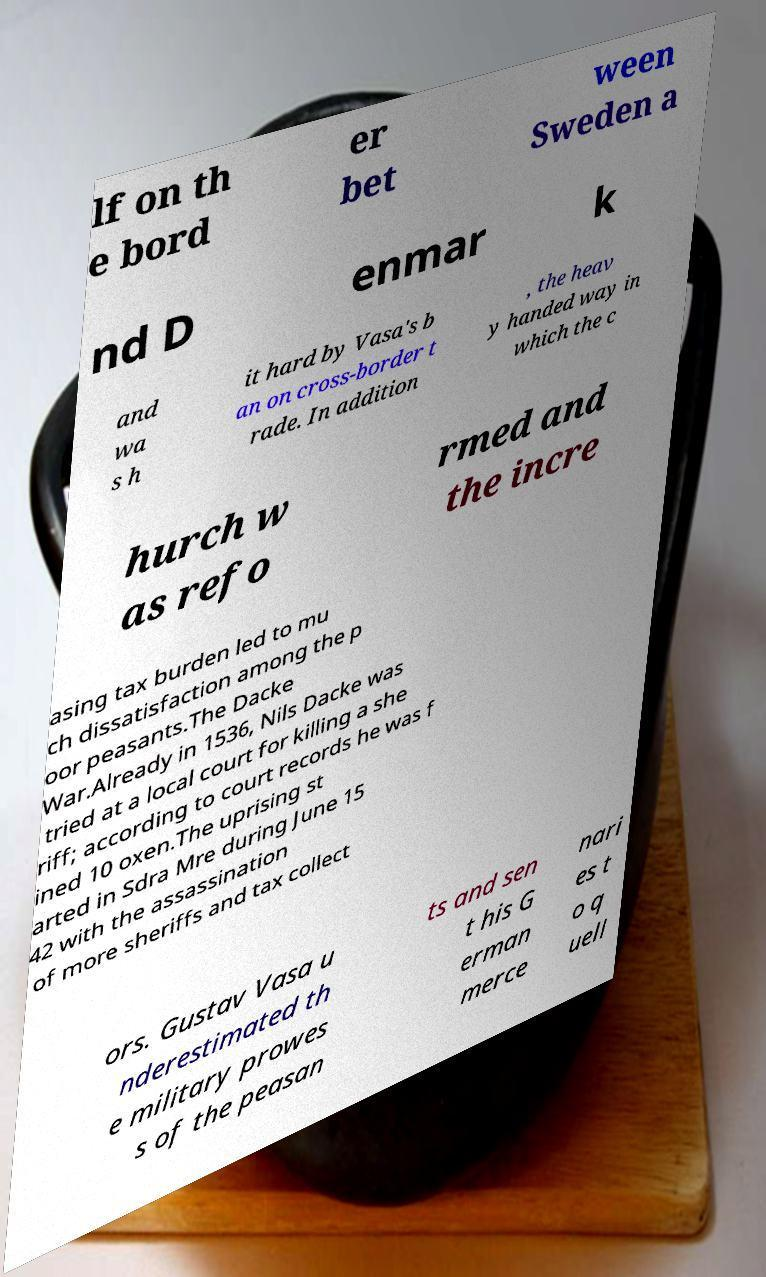For documentation purposes, I need the text within this image transcribed. Could you provide that? lf on th e bord er bet ween Sweden a nd D enmar k and wa s h it hard by Vasa's b an on cross-border t rade. In addition , the heav y handed way in which the c hurch w as refo rmed and the incre asing tax burden led to mu ch dissatisfaction among the p oor peasants.The Dacke War.Already in 1536, Nils Dacke was tried at a local court for killing a she riff; according to court records he was f ined 10 oxen.The uprising st arted in Sdra Mre during June 15 42 with the assassination of more sheriffs and tax collect ors. Gustav Vasa u nderestimated th e military prowes s of the peasan ts and sen t his G erman merce nari es t o q uell 